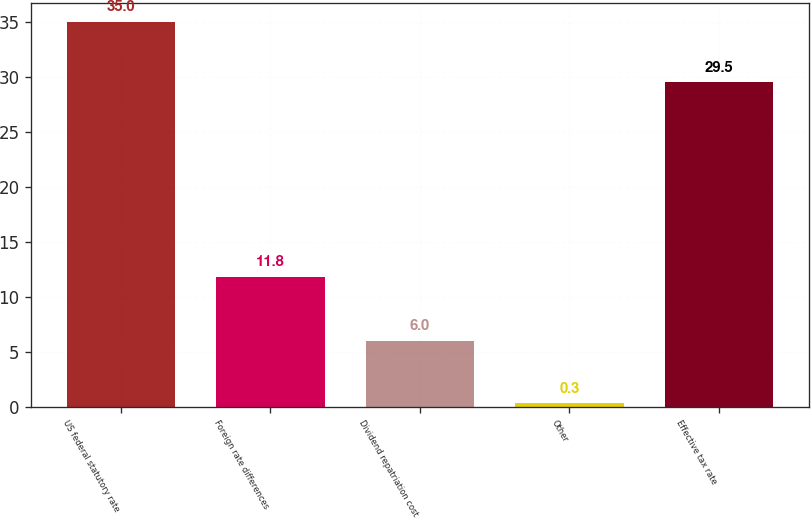Convert chart to OTSL. <chart><loc_0><loc_0><loc_500><loc_500><bar_chart><fcel>US federal statutory rate<fcel>Foreign rate differences<fcel>Dividend repatriation cost<fcel>Other<fcel>Effective tax rate<nl><fcel>35<fcel>11.8<fcel>6<fcel>0.3<fcel>29.5<nl></chart> 